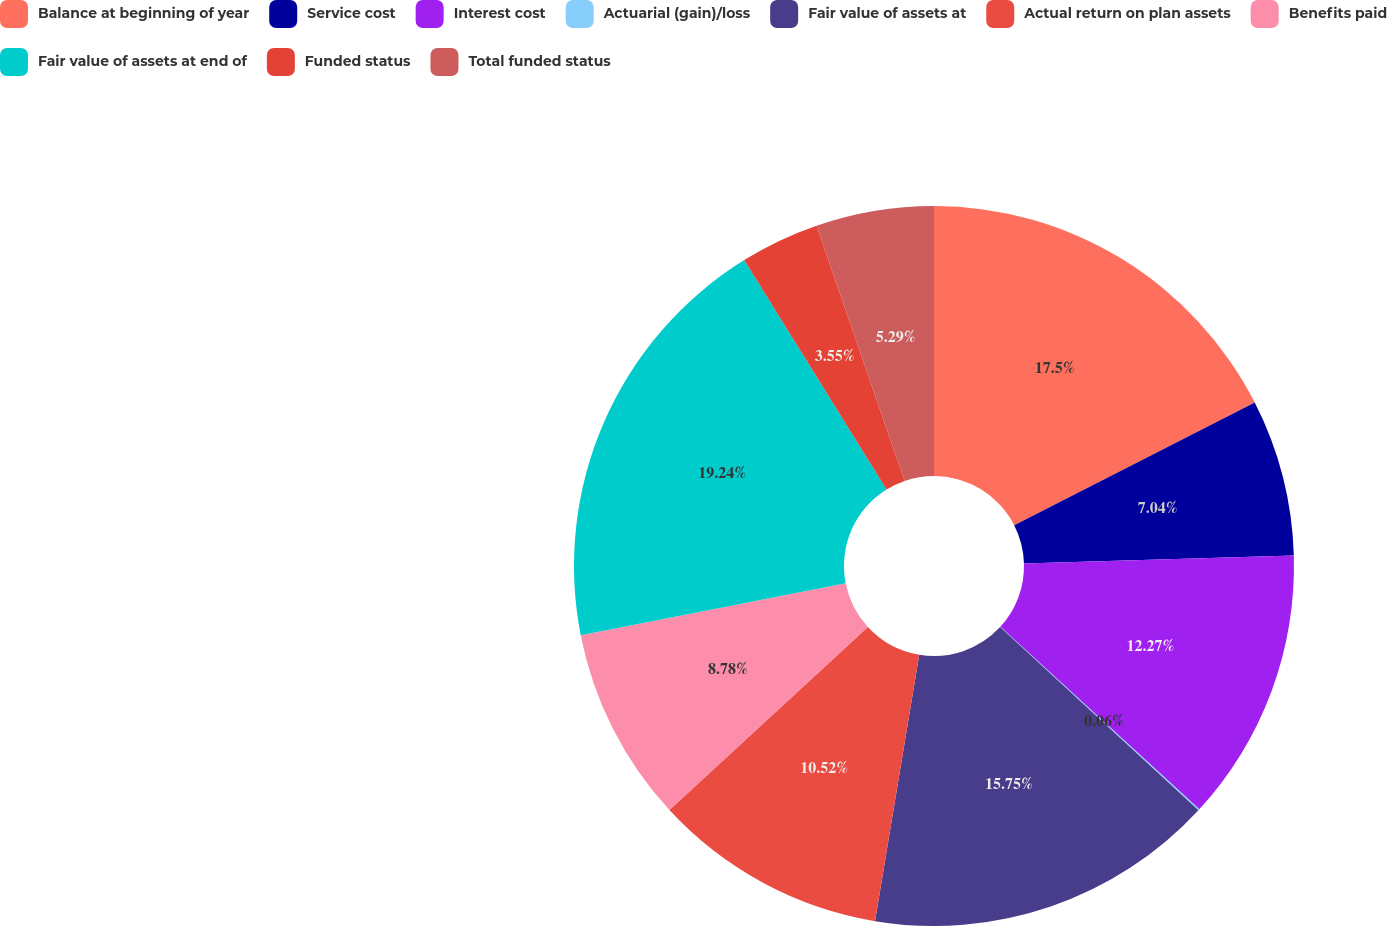Convert chart. <chart><loc_0><loc_0><loc_500><loc_500><pie_chart><fcel>Balance at beginning of year<fcel>Service cost<fcel>Interest cost<fcel>Actuarial (gain)/loss<fcel>Fair value of assets at<fcel>Actual return on plan assets<fcel>Benefits paid<fcel>Fair value of assets at end of<fcel>Funded status<fcel>Total funded status<nl><fcel>17.5%<fcel>7.04%<fcel>12.27%<fcel>0.06%<fcel>15.75%<fcel>10.52%<fcel>8.78%<fcel>19.24%<fcel>3.55%<fcel>5.29%<nl></chart> 